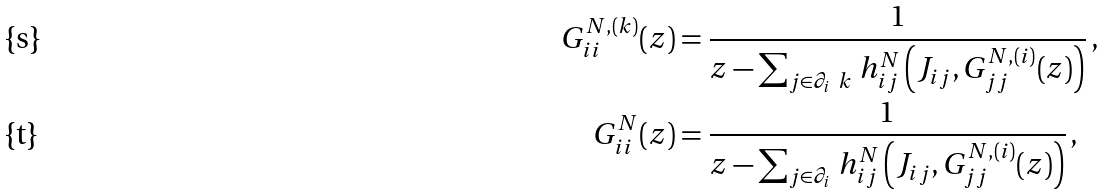Convert formula to latex. <formula><loc_0><loc_0><loc_500><loc_500>G ^ { N , ( k ) } _ { i i } ( z ) & = \frac { 1 } { z - \sum _ { j \in \partial _ { i } \ k } \, h ^ { N } _ { i j } \left ( J _ { i j } , G ^ { N , ( i ) } _ { j j } ( z ) \right ) } \, , \\ G ^ { N } _ { i i } ( z ) & = \frac { 1 } { z - \sum _ { j \in \partial _ { i } } \, h ^ { N } _ { i j } \left ( J _ { i j } , G ^ { N , ( i ) } _ { j j } ( z ) \right ) } \, ,</formula> 